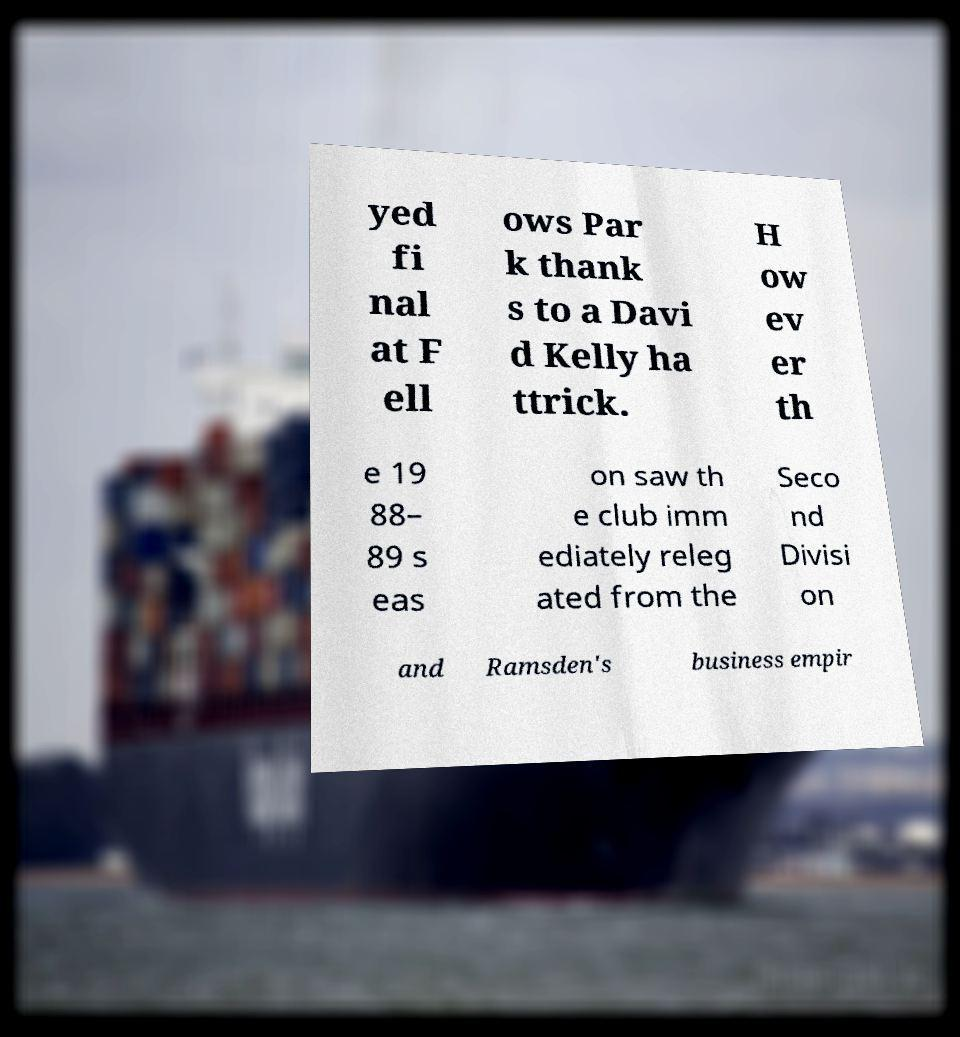There's text embedded in this image that I need extracted. Can you transcribe it verbatim? yed fi nal at F ell ows Par k thank s to a Davi d Kelly ha ttrick. H ow ev er th e 19 88– 89 s eas on saw th e club imm ediately releg ated from the Seco nd Divisi on and Ramsden's business empir 